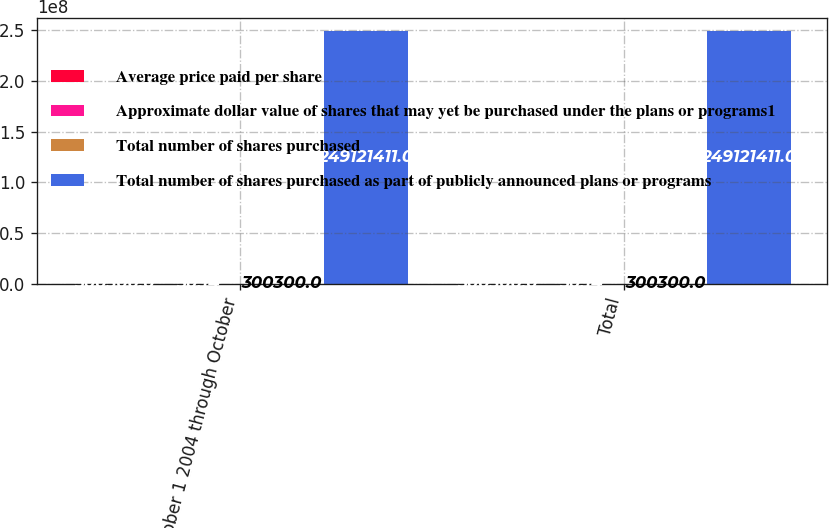Convert chart to OTSL. <chart><loc_0><loc_0><loc_500><loc_500><stacked_bar_chart><ecel><fcel>October 1 2004 through October<fcel>Total<nl><fcel>Average price paid per share<fcel>300300<fcel>300300<nl><fcel>Approximate dollar value of shares that may yet be purchased under the plans or programs1<fcel>30.14<fcel>30.14<nl><fcel>Total number of shares purchased<fcel>300300<fcel>300300<nl><fcel>Total number of shares purchased as part of publicly announced plans or programs<fcel>2.49121e+08<fcel>2.49121e+08<nl></chart> 